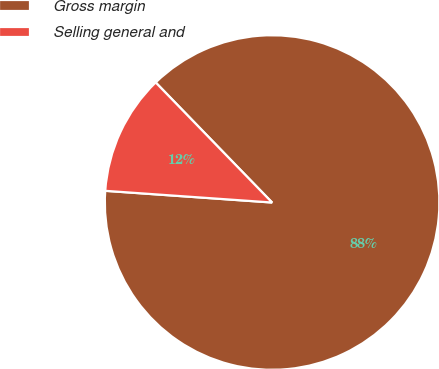<chart> <loc_0><loc_0><loc_500><loc_500><pie_chart><fcel>Gross margin<fcel>Selling general and<nl><fcel>88.37%<fcel>11.63%<nl></chart> 